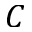<formula> <loc_0><loc_0><loc_500><loc_500>C</formula> 